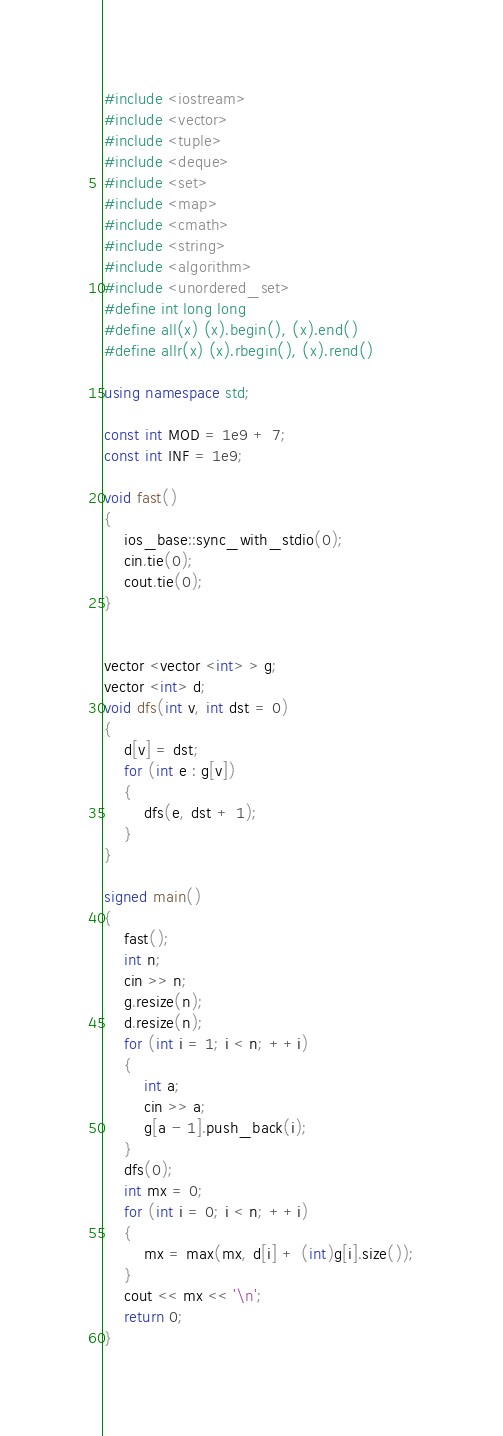Convert code to text. <code><loc_0><loc_0><loc_500><loc_500><_C++_>#include <iostream>
#include <vector>
#include <tuple>
#include <deque>
#include <set>
#include <map>
#include <cmath>
#include <string>
#include <algorithm>
#include <unordered_set>
#define int long long
#define all(x) (x).begin(), (x).end()
#define allr(x) (x).rbegin(), (x).rend()

using namespace std;

const int MOD = 1e9 + 7;
const int INF = 1e9;

void fast()
{
	ios_base::sync_with_stdio(0);
	cin.tie(0);
	cout.tie(0);
}


vector <vector <int> > g;
vector <int> d;
void dfs(int v, int dst = 0)
{
    d[v] = dst;
    for (int e : g[v])
    {
        dfs(e, dst + 1);
    }
}

signed main()
{
	fast();
    int n;
    cin >> n;
    g.resize(n);
    d.resize(n);
    for (int i = 1; i < n; ++i)
    {
        int a;
        cin >> a;
        g[a - 1].push_back(i);
    }
    dfs(0);
    int mx = 0;
    for (int i = 0; i < n; ++i)
    {
        mx = max(mx, d[i] + (int)g[i].size());
    }
    cout << mx << '\n';
    return 0;
}
</code> 